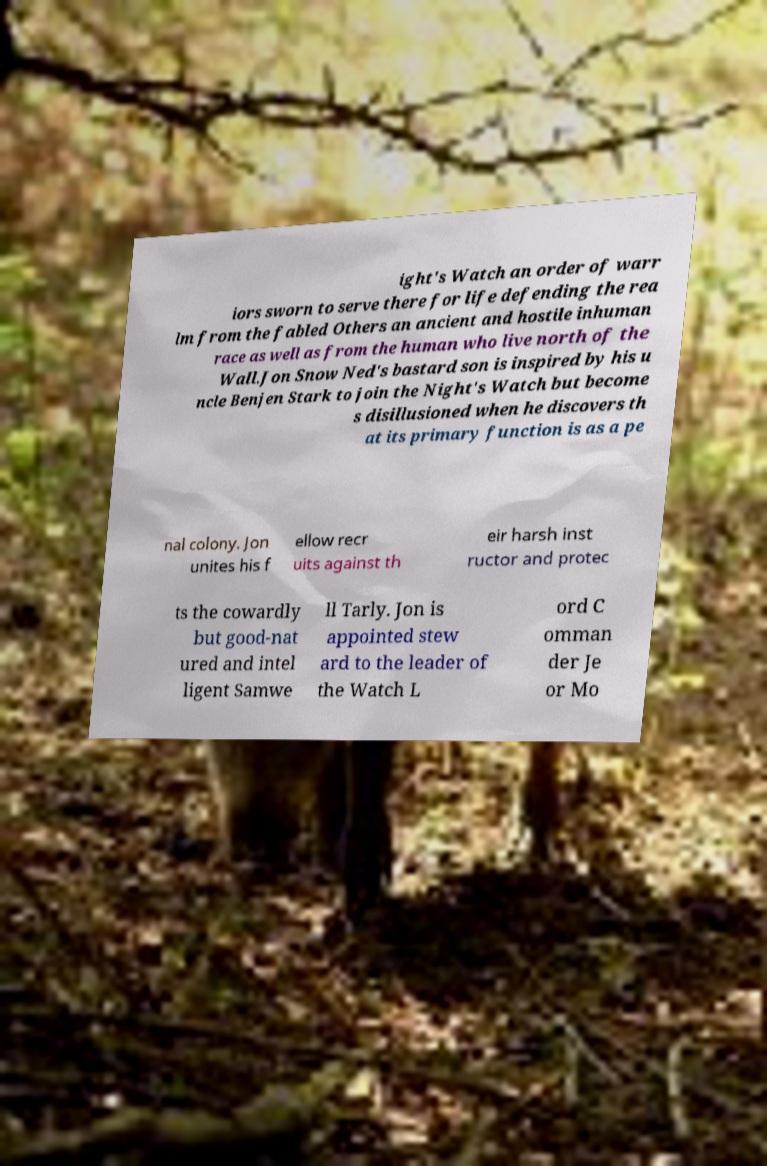Can you read and provide the text displayed in the image?This photo seems to have some interesting text. Can you extract and type it out for me? ight's Watch an order of warr iors sworn to serve there for life defending the rea lm from the fabled Others an ancient and hostile inhuman race as well as from the human who live north of the Wall.Jon Snow Ned's bastard son is inspired by his u ncle Benjen Stark to join the Night's Watch but become s disillusioned when he discovers th at its primary function is as a pe nal colony. Jon unites his f ellow recr uits against th eir harsh inst ructor and protec ts the cowardly but good-nat ured and intel ligent Samwe ll Tarly. Jon is appointed stew ard to the leader of the Watch L ord C omman der Je or Mo 